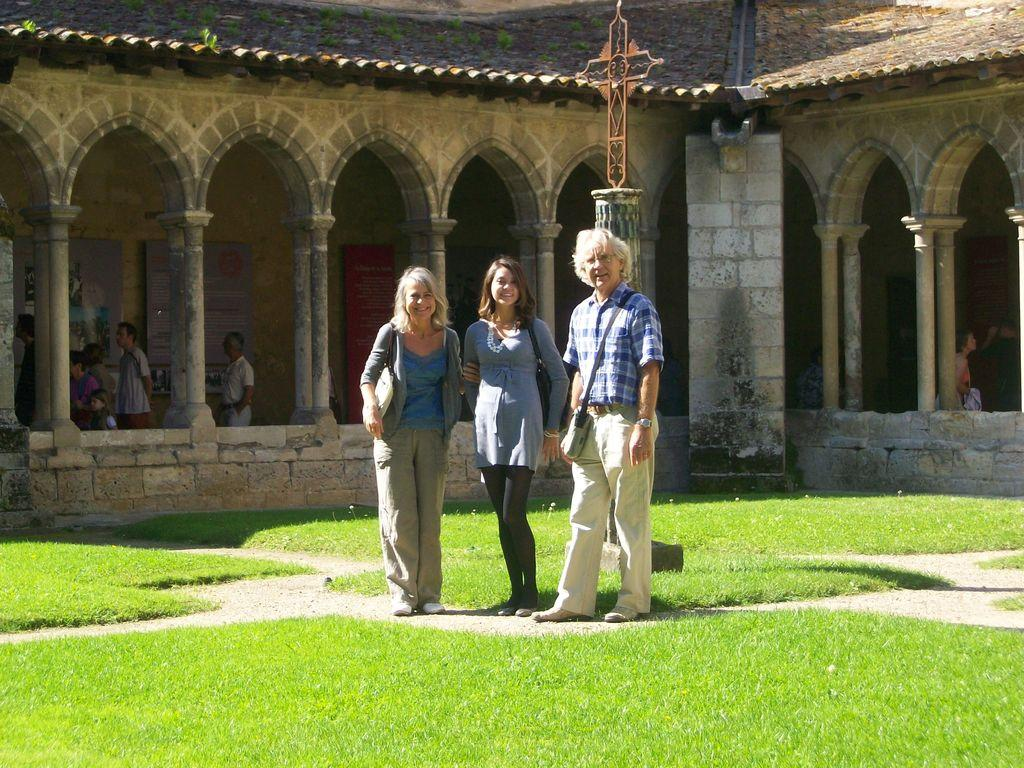How many people are in the image? There are three people standing in the image. What are the people doing in the image? The people are posing for the camera. What expressions do the people have on their faces? The people have smiles on their faces. What type of surface can be seen in the image? There is grass on the surface in the image. What can be seen in the background of the image? There are a few people visible in a house in the background. What type of apparatus is being used by the people in the image? There is no apparatus visible in the image; the people are simply standing and posing for the camera. Can you tell me how many books are on the grass in the image? There are no books present on the grass in the image. 